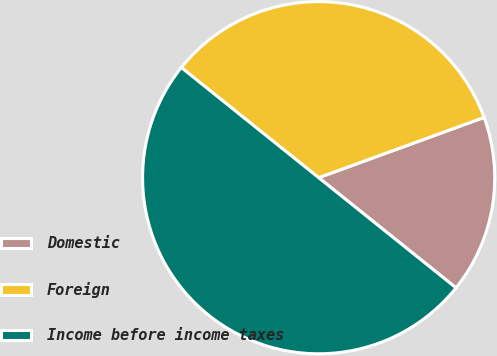Convert chart. <chart><loc_0><loc_0><loc_500><loc_500><pie_chart><fcel>Domestic<fcel>Foreign<fcel>Income before income taxes<nl><fcel>16.32%<fcel>33.68%<fcel>50.0%<nl></chart> 